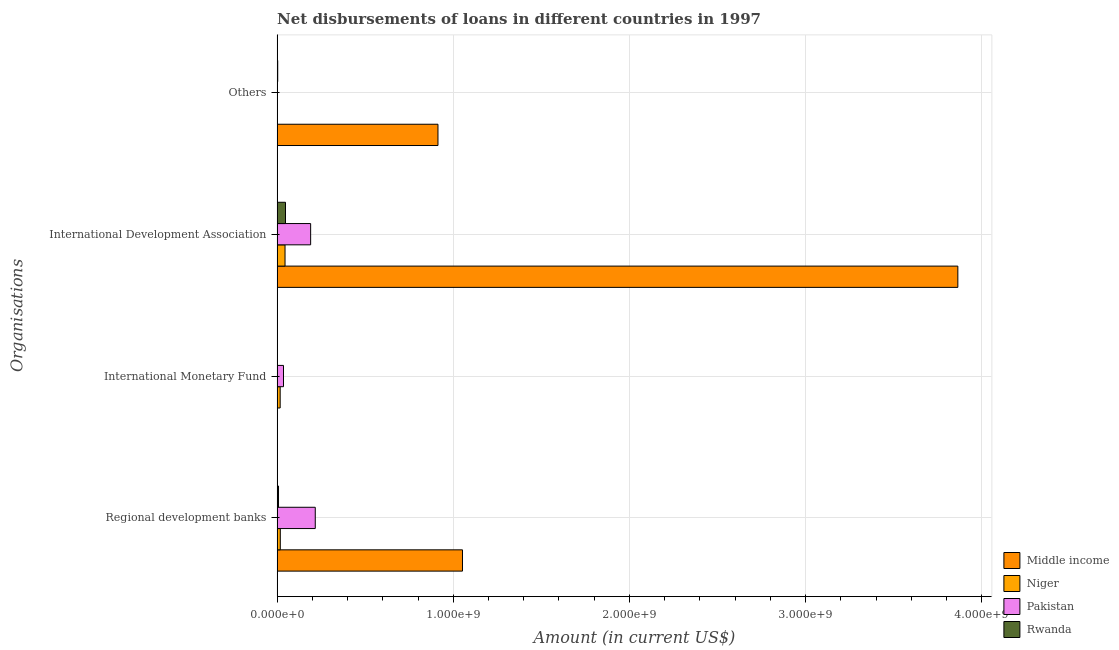How many different coloured bars are there?
Your response must be concise. 4. How many groups of bars are there?
Make the answer very short. 4. Are the number of bars per tick equal to the number of legend labels?
Offer a terse response. No. How many bars are there on the 2nd tick from the top?
Keep it short and to the point. 4. What is the label of the 3rd group of bars from the top?
Give a very brief answer. International Monetary Fund. Across all countries, what is the maximum amount of loan disimbursed by other organisations?
Ensure brevity in your answer.  9.13e+08. Across all countries, what is the minimum amount of loan disimbursed by other organisations?
Ensure brevity in your answer.  0. In which country was the amount of loan disimbursed by regional development banks maximum?
Your answer should be compact. Middle income. What is the total amount of loan disimbursed by other organisations in the graph?
Your answer should be very brief. 9.17e+08. What is the difference between the amount of loan disimbursed by international development association in Pakistan and that in Rwanda?
Offer a terse response. 1.43e+08. What is the difference between the amount of loan disimbursed by other organisations in Middle income and the amount of loan disimbursed by regional development banks in Rwanda?
Provide a short and direct response. 9.05e+08. What is the average amount of loan disimbursed by international monetary fund per country?
Offer a terse response. 1.34e+07. What is the difference between the amount of loan disimbursed by international development association and amount of loan disimbursed by regional development banks in Niger?
Provide a short and direct response. 2.68e+07. What is the ratio of the amount of loan disimbursed by international development association in Middle income to that in Rwanda?
Your response must be concise. 81.31. What is the difference between the highest and the second highest amount of loan disimbursed by regional development banks?
Keep it short and to the point. 8.36e+08. What is the difference between the highest and the lowest amount of loan disimbursed by other organisations?
Provide a short and direct response. 9.13e+08. In how many countries, is the amount of loan disimbursed by international monetary fund greater than the average amount of loan disimbursed by international monetary fund taken over all countries?
Make the answer very short. 2. Is it the case that in every country, the sum of the amount of loan disimbursed by regional development banks and amount of loan disimbursed by international monetary fund is greater than the sum of amount of loan disimbursed by other organisations and amount of loan disimbursed by international development association?
Give a very brief answer. No. How many bars are there?
Your answer should be very brief. 12. How many countries are there in the graph?
Give a very brief answer. 4. Does the graph contain grids?
Your answer should be compact. Yes. Where does the legend appear in the graph?
Give a very brief answer. Bottom right. How many legend labels are there?
Make the answer very short. 4. How are the legend labels stacked?
Provide a succinct answer. Vertical. What is the title of the graph?
Provide a succinct answer. Net disbursements of loans in different countries in 1997. Does "Somalia" appear as one of the legend labels in the graph?
Offer a very short reply. No. What is the label or title of the X-axis?
Offer a terse response. Amount (in current US$). What is the label or title of the Y-axis?
Provide a succinct answer. Organisations. What is the Amount (in current US$) of Middle income in Regional development banks?
Your answer should be very brief. 1.05e+09. What is the Amount (in current US$) of Niger in Regional development banks?
Make the answer very short. 1.80e+07. What is the Amount (in current US$) in Pakistan in Regional development banks?
Your response must be concise. 2.16e+08. What is the Amount (in current US$) of Rwanda in Regional development banks?
Offer a very short reply. 7.89e+06. What is the Amount (in current US$) of Niger in International Monetary Fund?
Your response must be concise. 1.73e+07. What is the Amount (in current US$) in Pakistan in International Monetary Fund?
Your answer should be very brief. 3.62e+07. What is the Amount (in current US$) of Middle income in International Development Association?
Offer a very short reply. 3.86e+09. What is the Amount (in current US$) in Niger in International Development Association?
Provide a succinct answer. 4.49e+07. What is the Amount (in current US$) in Pakistan in International Development Association?
Ensure brevity in your answer.  1.90e+08. What is the Amount (in current US$) in Rwanda in International Development Association?
Your answer should be very brief. 4.75e+07. What is the Amount (in current US$) of Middle income in Others?
Your response must be concise. 9.13e+08. What is the Amount (in current US$) in Niger in Others?
Your response must be concise. 0. What is the Amount (in current US$) of Rwanda in Others?
Your response must be concise. 3.41e+06. Across all Organisations, what is the maximum Amount (in current US$) of Middle income?
Offer a very short reply. 3.86e+09. Across all Organisations, what is the maximum Amount (in current US$) of Niger?
Your answer should be very brief. 4.49e+07. Across all Organisations, what is the maximum Amount (in current US$) in Pakistan?
Provide a short and direct response. 2.16e+08. Across all Organisations, what is the maximum Amount (in current US$) of Rwanda?
Offer a very short reply. 4.75e+07. Across all Organisations, what is the minimum Amount (in current US$) of Niger?
Your answer should be compact. 0. Across all Organisations, what is the minimum Amount (in current US$) in Pakistan?
Your response must be concise. 0. Across all Organisations, what is the minimum Amount (in current US$) in Rwanda?
Your answer should be compact. 0. What is the total Amount (in current US$) in Middle income in the graph?
Offer a terse response. 5.83e+09. What is the total Amount (in current US$) in Niger in the graph?
Provide a succinct answer. 8.02e+07. What is the total Amount (in current US$) in Pakistan in the graph?
Your answer should be compact. 4.43e+08. What is the total Amount (in current US$) of Rwanda in the graph?
Give a very brief answer. 5.88e+07. What is the difference between the Amount (in current US$) in Niger in Regional development banks and that in International Monetary Fund?
Provide a succinct answer. 7.37e+05. What is the difference between the Amount (in current US$) of Pakistan in Regional development banks and that in International Monetary Fund?
Keep it short and to the point. 1.80e+08. What is the difference between the Amount (in current US$) of Middle income in Regional development banks and that in International Development Association?
Provide a succinct answer. -2.81e+09. What is the difference between the Amount (in current US$) in Niger in Regional development banks and that in International Development Association?
Provide a succinct answer. -2.68e+07. What is the difference between the Amount (in current US$) in Pakistan in Regional development banks and that in International Development Association?
Your response must be concise. 2.62e+07. What is the difference between the Amount (in current US$) of Rwanda in Regional development banks and that in International Development Association?
Make the answer very short. -3.96e+07. What is the difference between the Amount (in current US$) of Middle income in Regional development banks and that in Others?
Your response must be concise. 1.39e+08. What is the difference between the Amount (in current US$) in Rwanda in Regional development banks and that in Others?
Your answer should be compact. 4.48e+06. What is the difference between the Amount (in current US$) of Niger in International Monetary Fund and that in International Development Association?
Offer a very short reply. -2.76e+07. What is the difference between the Amount (in current US$) in Pakistan in International Monetary Fund and that in International Development Association?
Provide a succinct answer. -1.54e+08. What is the difference between the Amount (in current US$) of Middle income in International Development Association and that in Others?
Your answer should be compact. 2.95e+09. What is the difference between the Amount (in current US$) of Rwanda in International Development Association and that in Others?
Offer a very short reply. 4.41e+07. What is the difference between the Amount (in current US$) of Middle income in Regional development banks and the Amount (in current US$) of Niger in International Monetary Fund?
Your response must be concise. 1.03e+09. What is the difference between the Amount (in current US$) in Middle income in Regional development banks and the Amount (in current US$) in Pakistan in International Monetary Fund?
Your answer should be very brief. 1.02e+09. What is the difference between the Amount (in current US$) of Niger in Regional development banks and the Amount (in current US$) of Pakistan in International Monetary Fund?
Give a very brief answer. -1.82e+07. What is the difference between the Amount (in current US$) in Middle income in Regional development banks and the Amount (in current US$) in Niger in International Development Association?
Provide a short and direct response. 1.01e+09. What is the difference between the Amount (in current US$) in Middle income in Regional development banks and the Amount (in current US$) in Pakistan in International Development Association?
Give a very brief answer. 8.62e+08. What is the difference between the Amount (in current US$) in Middle income in Regional development banks and the Amount (in current US$) in Rwanda in International Development Association?
Offer a very short reply. 1.00e+09. What is the difference between the Amount (in current US$) of Niger in Regional development banks and the Amount (in current US$) of Pakistan in International Development Association?
Make the answer very short. -1.72e+08. What is the difference between the Amount (in current US$) of Niger in Regional development banks and the Amount (in current US$) of Rwanda in International Development Association?
Offer a terse response. -2.95e+07. What is the difference between the Amount (in current US$) in Pakistan in Regional development banks and the Amount (in current US$) in Rwanda in International Development Association?
Make the answer very short. 1.69e+08. What is the difference between the Amount (in current US$) in Middle income in Regional development banks and the Amount (in current US$) in Rwanda in Others?
Provide a succinct answer. 1.05e+09. What is the difference between the Amount (in current US$) of Niger in Regional development banks and the Amount (in current US$) of Rwanda in Others?
Give a very brief answer. 1.46e+07. What is the difference between the Amount (in current US$) of Pakistan in Regional development banks and the Amount (in current US$) of Rwanda in Others?
Your answer should be compact. 2.13e+08. What is the difference between the Amount (in current US$) of Niger in International Monetary Fund and the Amount (in current US$) of Pakistan in International Development Association?
Your response must be concise. -1.73e+08. What is the difference between the Amount (in current US$) in Niger in International Monetary Fund and the Amount (in current US$) in Rwanda in International Development Association?
Give a very brief answer. -3.02e+07. What is the difference between the Amount (in current US$) in Pakistan in International Monetary Fund and the Amount (in current US$) in Rwanda in International Development Association?
Offer a very short reply. -1.13e+07. What is the difference between the Amount (in current US$) of Niger in International Monetary Fund and the Amount (in current US$) of Rwanda in Others?
Offer a very short reply. 1.39e+07. What is the difference between the Amount (in current US$) in Pakistan in International Monetary Fund and the Amount (in current US$) in Rwanda in Others?
Give a very brief answer. 3.28e+07. What is the difference between the Amount (in current US$) of Middle income in International Development Association and the Amount (in current US$) of Rwanda in Others?
Provide a succinct answer. 3.86e+09. What is the difference between the Amount (in current US$) in Niger in International Development Association and the Amount (in current US$) in Rwanda in Others?
Keep it short and to the point. 4.15e+07. What is the difference between the Amount (in current US$) in Pakistan in International Development Association and the Amount (in current US$) in Rwanda in Others?
Make the answer very short. 1.87e+08. What is the average Amount (in current US$) of Middle income per Organisations?
Ensure brevity in your answer.  1.46e+09. What is the average Amount (in current US$) of Niger per Organisations?
Offer a terse response. 2.01e+07. What is the average Amount (in current US$) of Pakistan per Organisations?
Make the answer very short. 1.11e+08. What is the average Amount (in current US$) of Rwanda per Organisations?
Your response must be concise. 1.47e+07. What is the difference between the Amount (in current US$) of Middle income and Amount (in current US$) of Niger in Regional development banks?
Provide a succinct answer. 1.03e+09. What is the difference between the Amount (in current US$) of Middle income and Amount (in current US$) of Pakistan in Regional development banks?
Give a very brief answer. 8.36e+08. What is the difference between the Amount (in current US$) in Middle income and Amount (in current US$) in Rwanda in Regional development banks?
Your answer should be compact. 1.04e+09. What is the difference between the Amount (in current US$) in Niger and Amount (in current US$) in Pakistan in Regional development banks?
Keep it short and to the point. -1.98e+08. What is the difference between the Amount (in current US$) of Niger and Amount (in current US$) of Rwanda in Regional development banks?
Provide a succinct answer. 1.02e+07. What is the difference between the Amount (in current US$) of Pakistan and Amount (in current US$) of Rwanda in Regional development banks?
Your response must be concise. 2.09e+08. What is the difference between the Amount (in current US$) of Niger and Amount (in current US$) of Pakistan in International Monetary Fund?
Offer a terse response. -1.89e+07. What is the difference between the Amount (in current US$) of Middle income and Amount (in current US$) of Niger in International Development Association?
Ensure brevity in your answer.  3.82e+09. What is the difference between the Amount (in current US$) of Middle income and Amount (in current US$) of Pakistan in International Development Association?
Offer a very short reply. 3.67e+09. What is the difference between the Amount (in current US$) in Middle income and Amount (in current US$) in Rwanda in International Development Association?
Your response must be concise. 3.82e+09. What is the difference between the Amount (in current US$) in Niger and Amount (in current US$) in Pakistan in International Development Association?
Your response must be concise. -1.45e+08. What is the difference between the Amount (in current US$) of Niger and Amount (in current US$) of Rwanda in International Development Association?
Your response must be concise. -2.65e+06. What is the difference between the Amount (in current US$) of Pakistan and Amount (in current US$) of Rwanda in International Development Association?
Ensure brevity in your answer.  1.43e+08. What is the difference between the Amount (in current US$) in Middle income and Amount (in current US$) in Rwanda in Others?
Ensure brevity in your answer.  9.10e+08. What is the ratio of the Amount (in current US$) of Niger in Regional development banks to that in International Monetary Fund?
Keep it short and to the point. 1.04. What is the ratio of the Amount (in current US$) in Pakistan in Regional development banks to that in International Monetary Fund?
Keep it short and to the point. 5.98. What is the ratio of the Amount (in current US$) in Middle income in Regional development banks to that in International Development Association?
Your answer should be compact. 0.27. What is the ratio of the Amount (in current US$) in Niger in Regional development banks to that in International Development Association?
Your answer should be compact. 0.4. What is the ratio of the Amount (in current US$) of Pakistan in Regional development banks to that in International Development Association?
Provide a short and direct response. 1.14. What is the ratio of the Amount (in current US$) of Rwanda in Regional development banks to that in International Development Association?
Ensure brevity in your answer.  0.17. What is the ratio of the Amount (in current US$) in Middle income in Regional development banks to that in Others?
Your response must be concise. 1.15. What is the ratio of the Amount (in current US$) in Rwanda in Regional development banks to that in Others?
Provide a short and direct response. 2.32. What is the ratio of the Amount (in current US$) of Niger in International Monetary Fund to that in International Development Association?
Ensure brevity in your answer.  0.39. What is the ratio of the Amount (in current US$) of Pakistan in International Monetary Fund to that in International Development Association?
Your answer should be compact. 0.19. What is the ratio of the Amount (in current US$) of Middle income in International Development Association to that in Others?
Your answer should be compact. 4.23. What is the ratio of the Amount (in current US$) in Rwanda in International Development Association to that in Others?
Your answer should be compact. 13.95. What is the difference between the highest and the second highest Amount (in current US$) of Middle income?
Keep it short and to the point. 2.81e+09. What is the difference between the highest and the second highest Amount (in current US$) of Niger?
Keep it short and to the point. 2.68e+07. What is the difference between the highest and the second highest Amount (in current US$) of Pakistan?
Keep it short and to the point. 2.62e+07. What is the difference between the highest and the second highest Amount (in current US$) of Rwanda?
Ensure brevity in your answer.  3.96e+07. What is the difference between the highest and the lowest Amount (in current US$) in Middle income?
Your answer should be compact. 3.86e+09. What is the difference between the highest and the lowest Amount (in current US$) in Niger?
Keep it short and to the point. 4.49e+07. What is the difference between the highest and the lowest Amount (in current US$) in Pakistan?
Your answer should be compact. 2.16e+08. What is the difference between the highest and the lowest Amount (in current US$) in Rwanda?
Offer a terse response. 4.75e+07. 